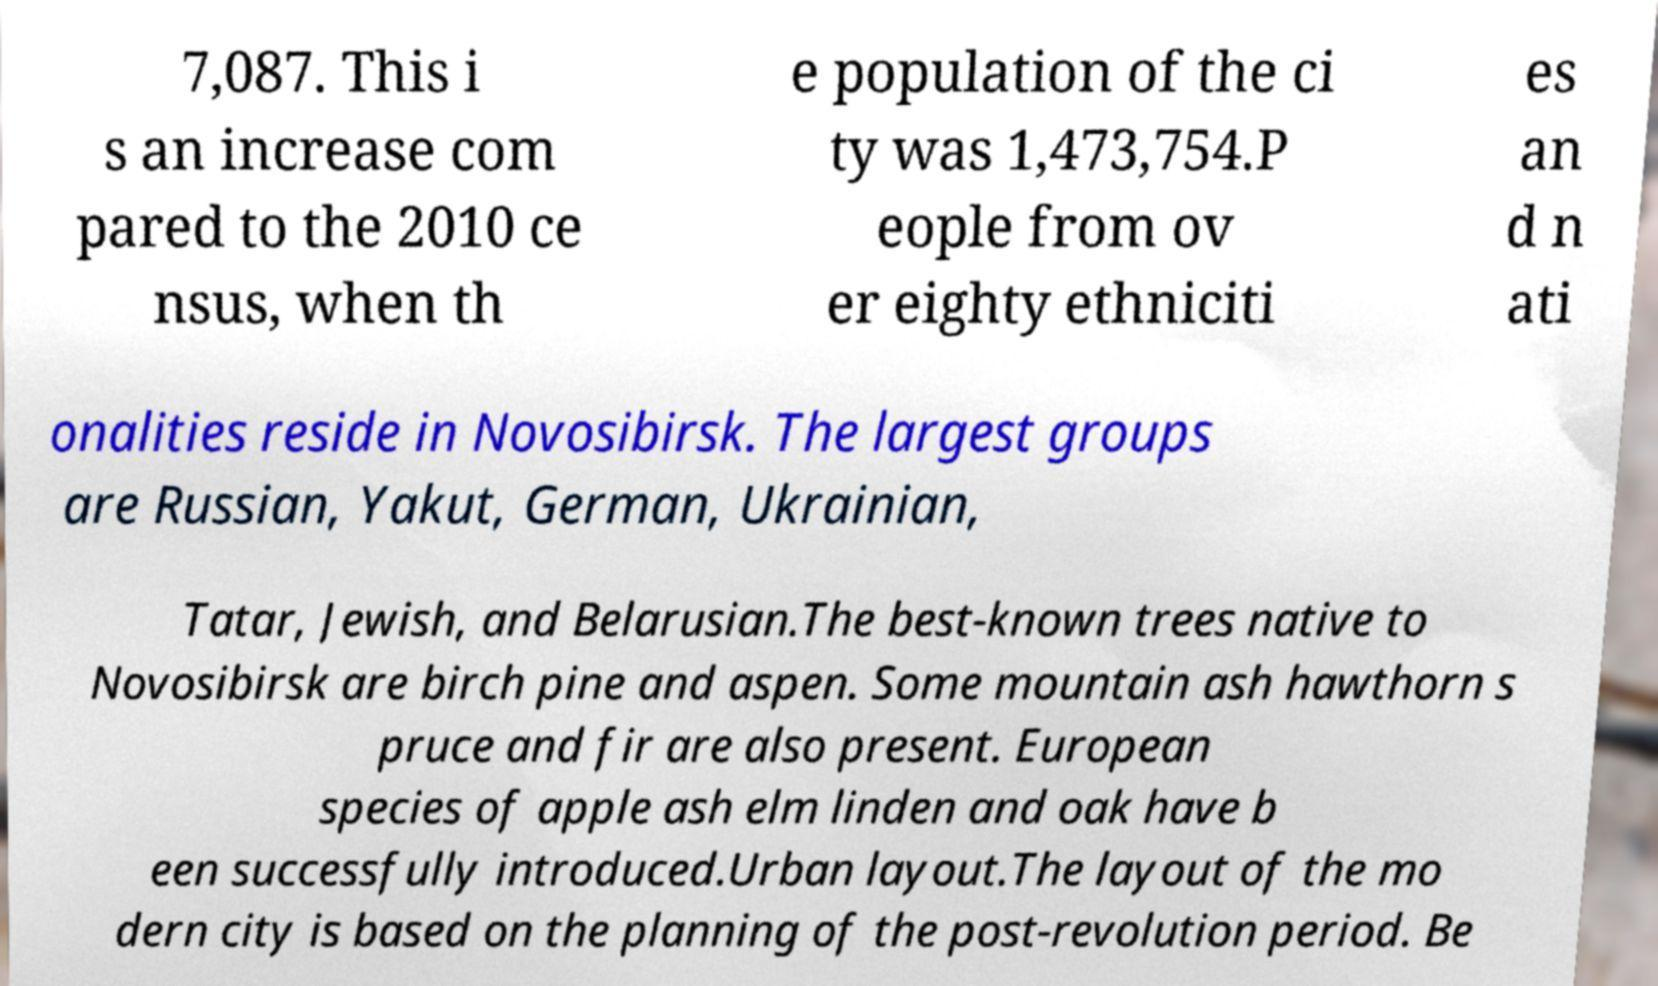I need the written content from this picture converted into text. Can you do that? 7,087. This i s an increase com pared to the 2010 ce nsus, when th e population of the ci ty was 1,473,754.P eople from ov er eighty ethniciti es an d n ati onalities reside in Novosibirsk. The largest groups are Russian, Yakut, German, Ukrainian, Tatar, Jewish, and Belarusian.The best-known trees native to Novosibirsk are birch pine and aspen. Some mountain ash hawthorn s pruce and fir are also present. European species of apple ash elm linden and oak have b een successfully introduced.Urban layout.The layout of the mo dern city is based on the planning of the post-revolution period. Be 